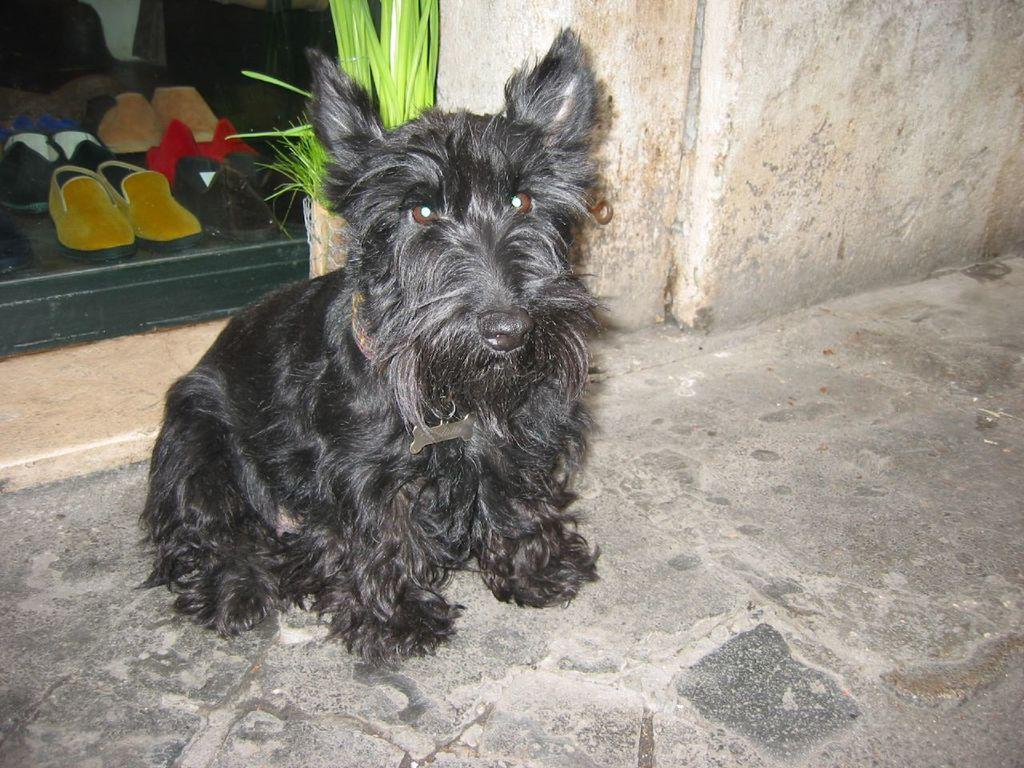What type of animal is in the image? There is a black dog in the image. Where is the dog located in the image? The dog is in the front of the image. What can be seen in the background of the image? There are footwear and a plant in the background of the image. What is the dog wearing around its neck? The dog is wearing a belt around its neck. What type of shade does the dog regret in the image? There is no indication of regret or shade in the image; it features a black dog in the front with a belt around its neck, and footwear and a plant in the background. 